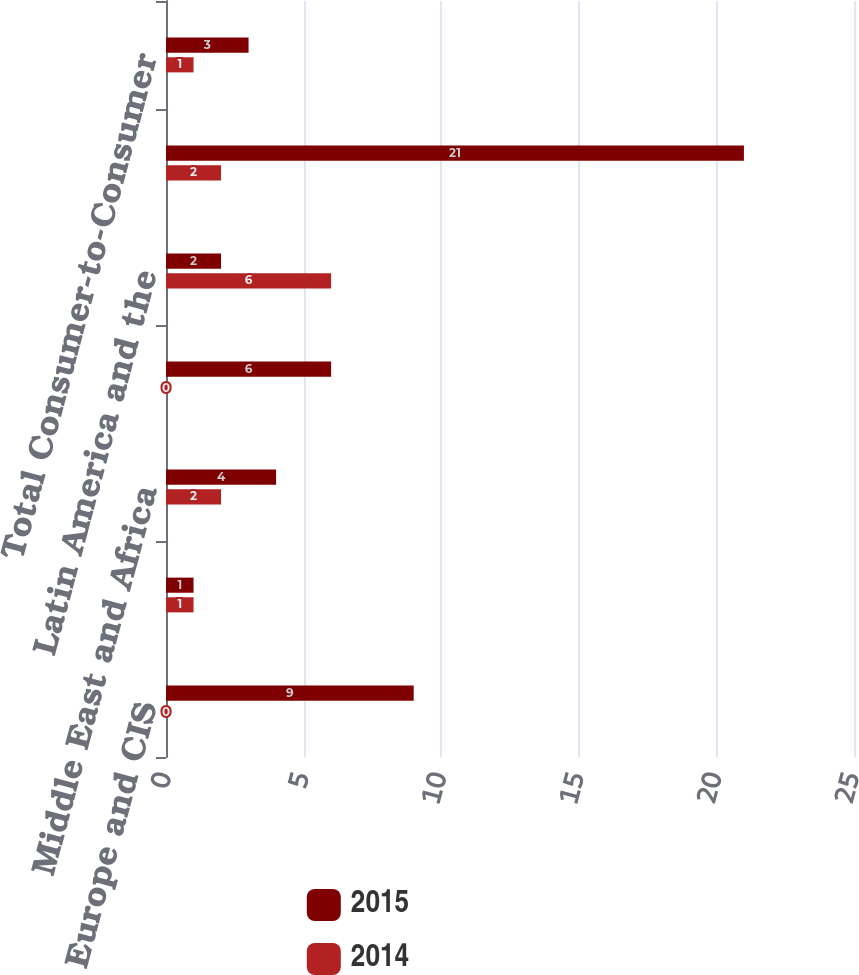Convert chart to OTSL. <chart><loc_0><loc_0><loc_500><loc_500><stacked_bar_chart><ecel><fcel>Europe and CIS<fcel>North America<fcel>Middle East and Africa<fcel>Asia Pacific (APAC)<fcel>Latin America and the<fcel>westernunioncom<fcel>Total Consumer-to-Consumer<nl><fcel>2015<fcel>9<fcel>1<fcel>4<fcel>6<fcel>2<fcel>21<fcel>3<nl><fcel>2014<fcel>0<fcel>1<fcel>2<fcel>0<fcel>6<fcel>2<fcel>1<nl></chart> 